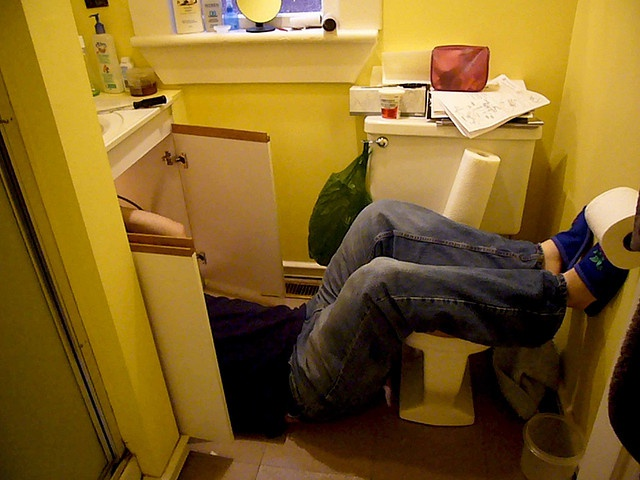Describe the objects in this image and their specific colors. I can see people in olive, black, gray, and maroon tones, toilet in olive and tan tones, sink in olive and tan tones, bottle in olive, tan, and orange tones, and bottle in olive and tan tones in this image. 